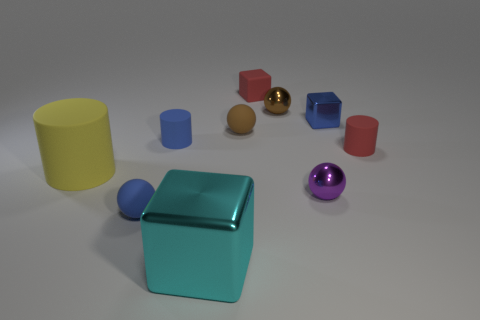Subtract all cylinders. How many objects are left? 7 Subtract 0 cyan cylinders. How many objects are left? 10 Subtract all small gray shiny blocks. Subtract all metallic blocks. How many objects are left? 8 Add 3 blue objects. How many blue objects are left? 6 Add 6 red cylinders. How many red cylinders exist? 7 